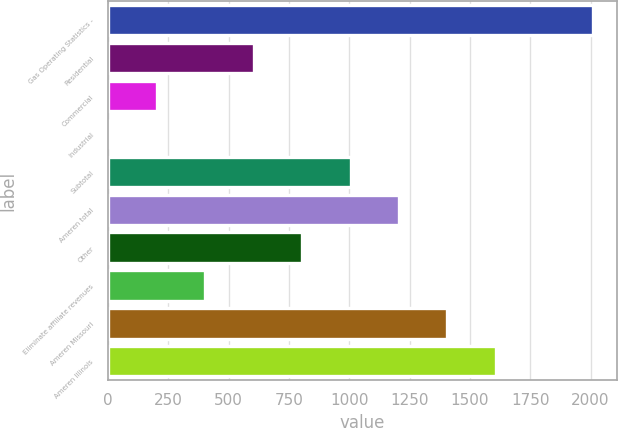<chart> <loc_0><loc_0><loc_500><loc_500><bar_chart><fcel>Gas Operating Statistics -<fcel>Residential<fcel>Commercial<fcel>Industrial<fcel>Subtotal<fcel>Ameren total<fcel>Other<fcel>Eliminate affiliate revenues<fcel>Ameren Missouri<fcel>Ameren Illinois<nl><fcel>2009<fcel>603.4<fcel>201.8<fcel>1<fcel>1005<fcel>1205.8<fcel>804.2<fcel>402.6<fcel>1406.6<fcel>1607.4<nl></chart> 